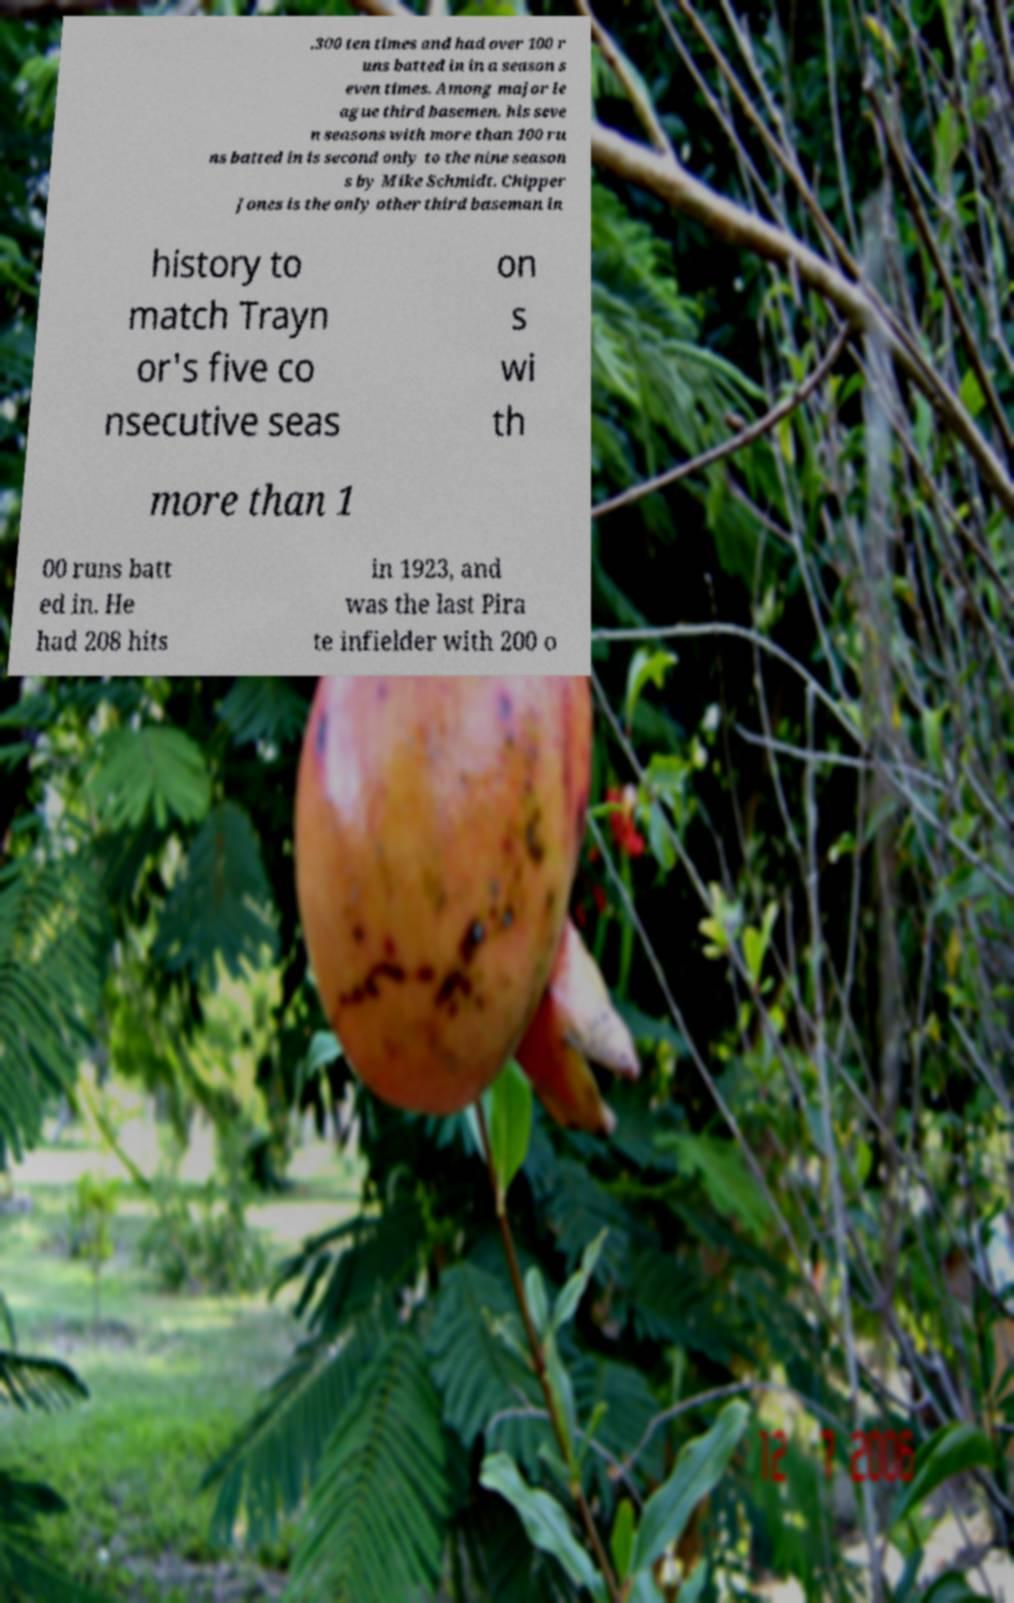Could you assist in decoding the text presented in this image and type it out clearly? .300 ten times and had over 100 r uns batted in in a season s even times. Among major le ague third basemen, his seve n seasons with more than 100 ru ns batted in is second only to the nine season s by Mike Schmidt. Chipper Jones is the only other third baseman in history to match Trayn or's five co nsecutive seas on s wi th more than 1 00 runs batt ed in. He had 208 hits in 1923, and was the last Pira te infielder with 200 o 